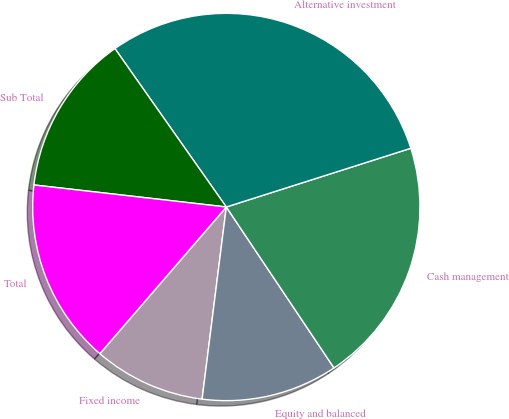Convert chart to OTSL. <chart><loc_0><loc_0><loc_500><loc_500><pie_chart><fcel>Fixed income<fcel>Equity and balanced<fcel>Cash management<fcel>Alternative investment<fcel>Sub Total<fcel>Total<nl><fcel>9.33%<fcel>11.38%<fcel>20.52%<fcel>29.85%<fcel>13.43%<fcel>15.49%<nl></chart> 